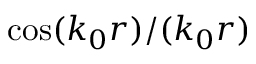<formula> <loc_0><loc_0><loc_500><loc_500>\cos ( k _ { 0 } r ) / ( k _ { 0 } r )</formula> 